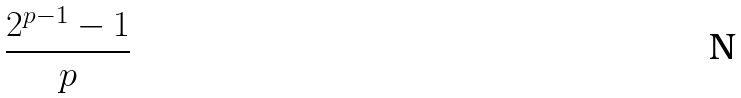<formula> <loc_0><loc_0><loc_500><loc_500>\frac { 2 ^ { p - 1 } - 1 } { p }</formula> 